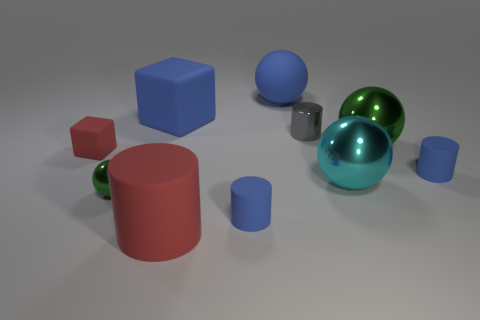How big is the object that is both in front of the large green shiny object and right of the cyan metal ball?
Keep it short and to the point. Small. How many other gray objects are the same size as the gray shiny object?
Give a very brief answer. 0. How big is the blue thing that is on the right side of the green sphere behind the red matte cube?
Provide a short and direct response. Small. Is the shape of the small metal object that is on the left side of the red rubber cylinder the same as the green thing behind the small red matte block?
Give a very brief answer. Yes. What is the color of the thing that is both on the left side of the large red object and behind the shiny cylinder?
Make the answer very short. Blue. Is there another big cube of the same color as the big block?
Make the answer very short. No. There is a rubber cylinder that is behind the small green shiny thing; what is its color?
Provide a succinct answer. Blue. There is a big shiny sphere that is left of the big green metal thing; are there any small green spheres that are behind it?
Make the answer very short. No. There is a big rubber cylinder; is it the same color as the metallic sphere that is behind the red matte cube?
Make the answer very short. No. Are there any big things that have the same material as the big blue cube?
Ensure brevity in your answer.  Yes. 